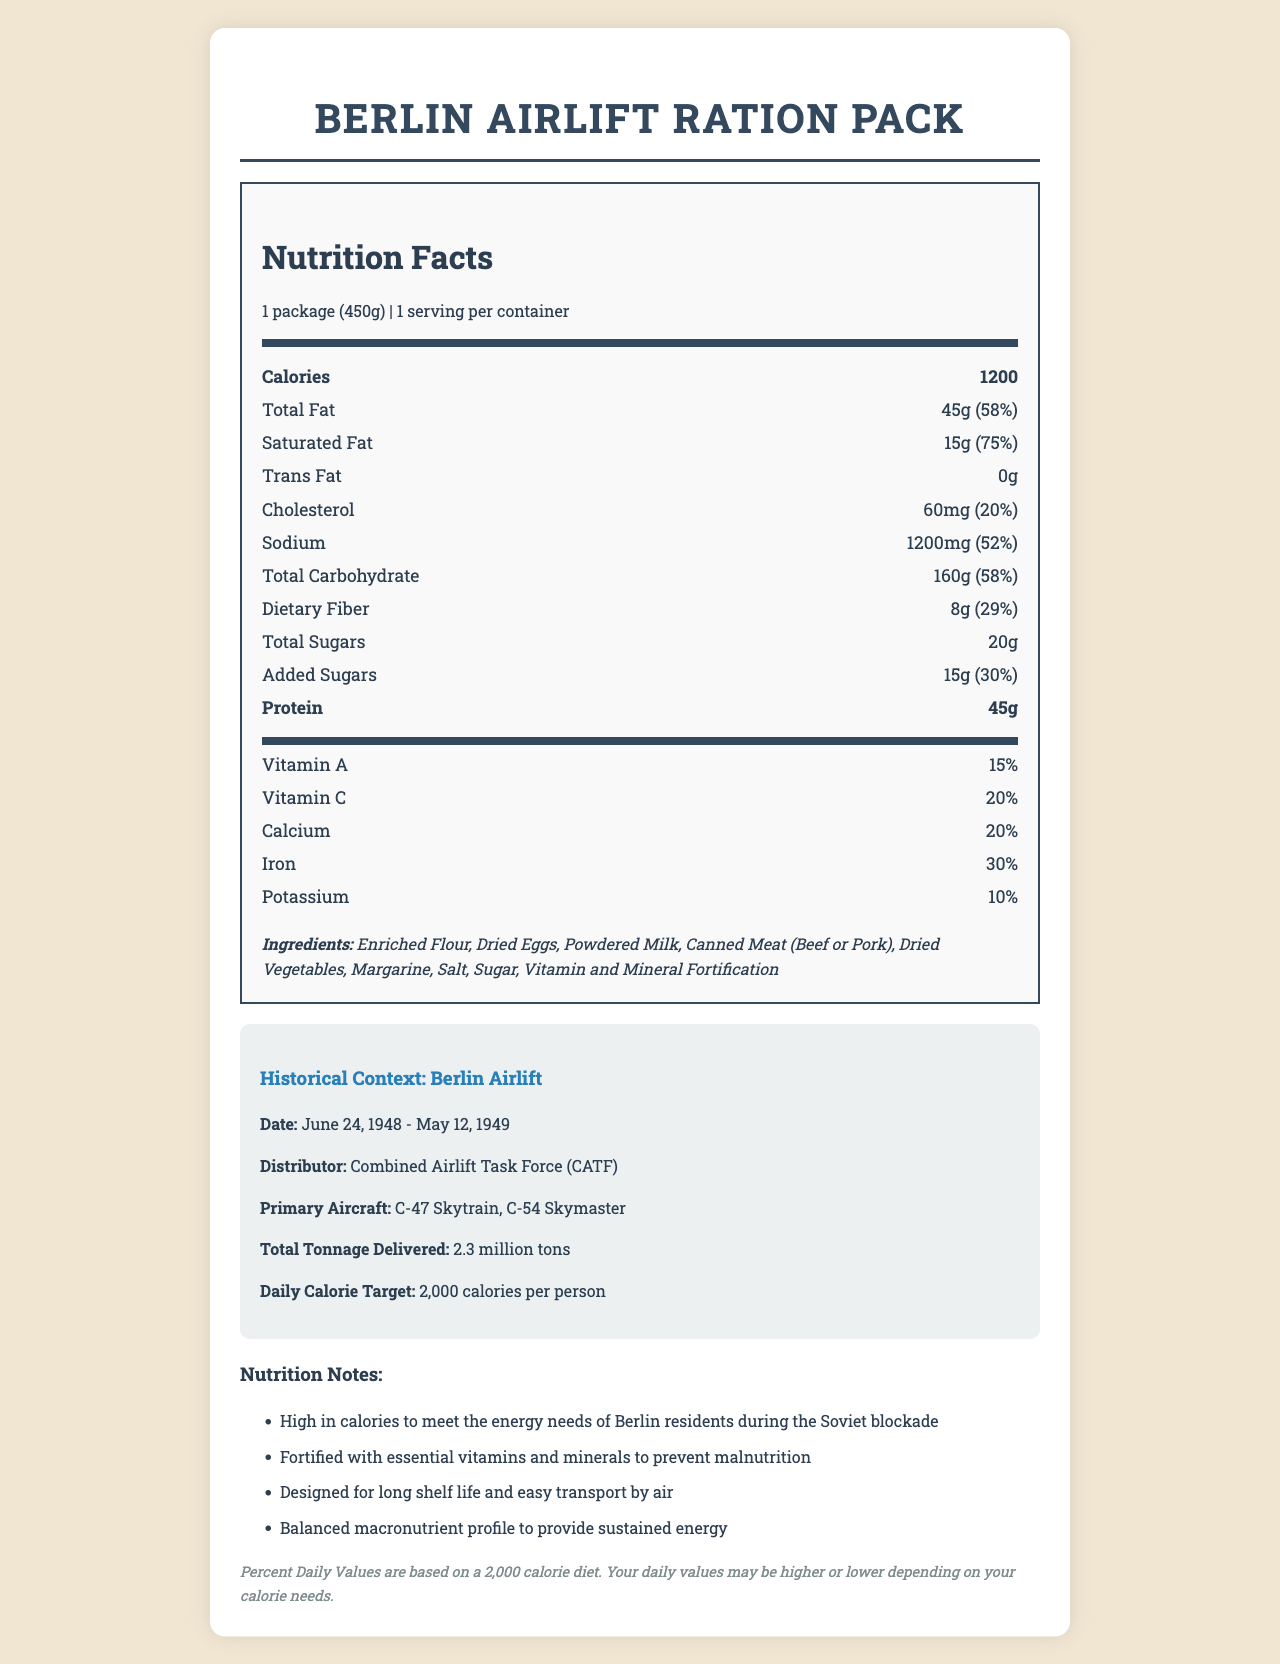What is the serving size of the Berlin Airlift Ration Pack? The document specifies that the serving size is 1 package, which weighs 450 grams.
Answer: 1 package (450g) How many calories are there in one serving of the Berlin Airlift Ration Pack? The nutrition label clearly states that there are 1200 calories per serving.
Answer: 1200 calories What percentage of the Daily Value is provided by the total fat content in the Berlin Airlift Ration Pack? The document mentions that the total fat amount is 45g and it corresponds to 58% of the Daily Value.
Answer: 58% What are the main ingredients in the Berlin Airlift Ration Pack? The ingredients are listed in the document.
Answer: Enriched Flour, Dried Eggs, Powdered Milk, Canned Meat (Beef or Pork), Dried Vegetables, Margarine, Salt, Sugar, Vitamin and Mineral Fortification What were the primary aircraft used for the Berlin Airlift? The historical context section of the document lists these aircraft as the primary ones used during the Berlin Airlift.
Answer: C-47 Skytrain, C-54 Skymaster What is the daily calorie target mentioned in the document? A. 1500 calories B. 2000 calories C. 2500 calories D. 3000 calories The historical context section mentions that the daily calorie target was 2000 calories per person.
Answer: B. 2000 calories Which of the following nutrients has the highest percentage of the Daily Value in the Berlin Airlift Ration Pack? I. Total Fat II. Saturated Fat III. Sodium IV. Total Carbohydrate The document notes that saturated fat provides 75% of the Daily Value, which is higher than the percentages for total fat, sodium, and total carbohydrate.
Answer: II. Saturated Fat Is the Berlin Airlift Ration Pack high in sodium? The document states that the ration pack contains 1200mg of sodium, which is 52% of the Daily Value, indicating high sodium content.
Answer: Yes What was the total tonnage of supplies delivered during the Berlin Airlift, according to the historical context? The document specifies that the total tonnage delivered was 2.3 million tons.
Answer: 2.3 million tons Summarize the main nutrition facts of the Berlin Airlift Ration Pack described in the document. The document lists detailed nutrition information, showing high caloric content with substantial amounts of macronutrients and vital vitamins and minerals. It highlights the pack's design to meet the energy requirements of Berlin residents during the blockade.
Answer: The Berlin Airlift Ration Pack contains 1200 calories per serving, with high amounts of fat, protein, and carbohydrates. It includes significant amounts of essential vitamins and minerals. The pack is designed to meet energy needs during the Berlin blockade and contains long-shelf life ingredients. What were the main challenges faced during the Berlin Airlift operation? The document specifies the logistical details but does not provide information on the challenges faced during the Berlin Airlift operation.
Answer: Not enough information 